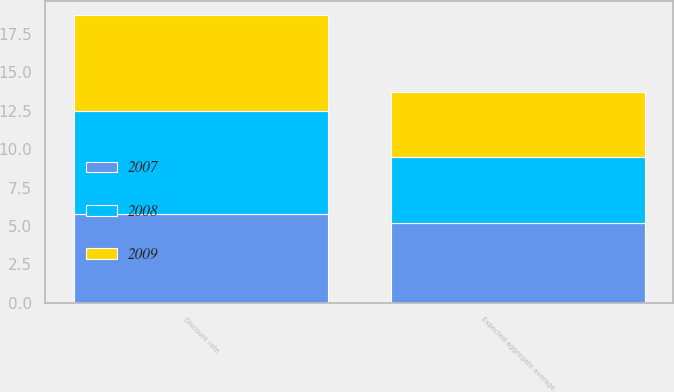Convert chart. <chart><loc_0><loc_0><loc_500><loc_500><stacked_bar_chart><ecel><fcel>Discount rate<fcel>Expected aggregate average<nl><fcel>2007<fcel>5.8<fcel>5.2<nl><fcel>2008<fcel>6.7<fcel>4.3<nl><fcel>2009<fcel>6.2<fcel>4.2<nl></chart> 